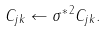<formula> <loc_0><loc_0><loc_500><loc_500>C _ { j k } \leftarrow \sigma ^ { * \, 2 } C _ { j k } .</formula> 